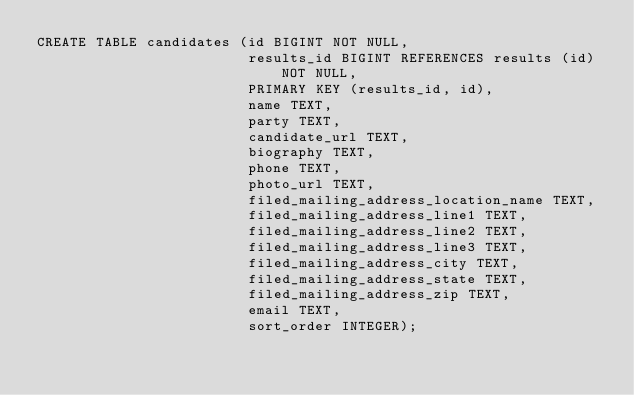<code> <loc_0><loc_0><loc_500><loc_500><_SQL_>CREATE TABLE candidates (id BIGINT NOT NULL,
                         results_id BIGINT REFERENCES results (id) NOT NULL,
                         PRIMARY KEY (results_id, id),
                         name TEXT,
                         party TEXT,
                         candidate_url TEXT,
                         biography TEXT,
                         phone TEXT,
                         photo_url TEXT,
                         filed_mailing_address_location_name TEXT,
                         filed_mailing_address_line1 TEXT,
                         filed_mailing_address_line2 TEXT,
                         filed_mailing_address_line3 TEXT,
                         filed_mailing_address_city TEXT,
                         filed_mailing_address_state TEXT,
                         filed_mailing_address_zip TEXT,
                         email TEXT,
                         sort_order INTEGER);
</code> 